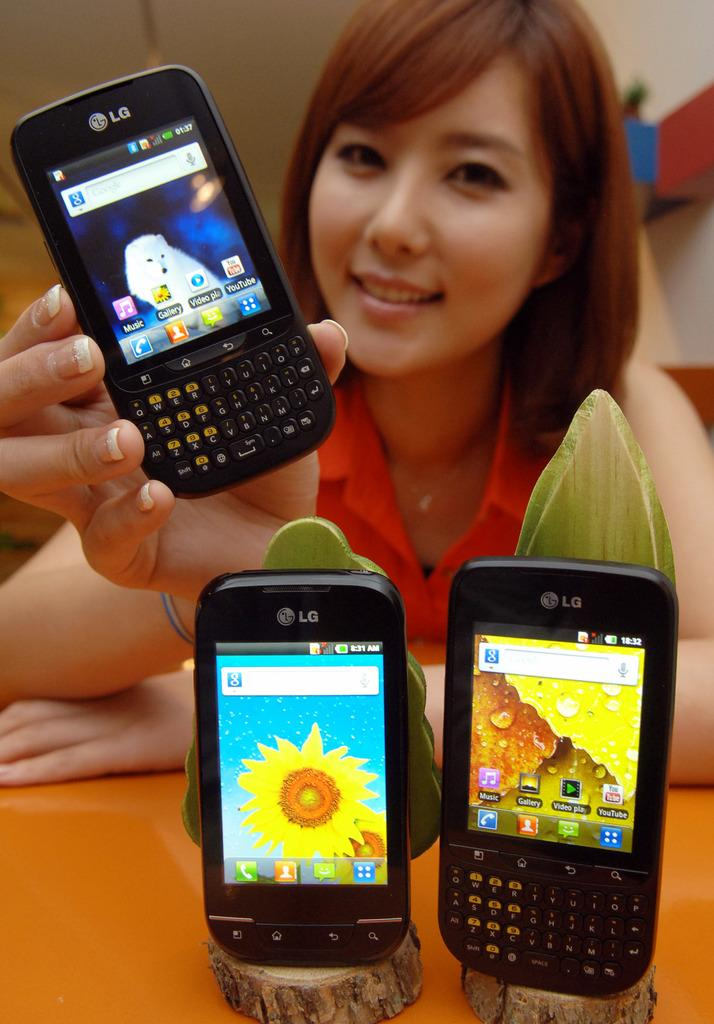<image>
Describe the image concisely. Two cell phones both are LG model, one has a Sunflower on the screen and the other has a qwerty keyboard on the screen. 